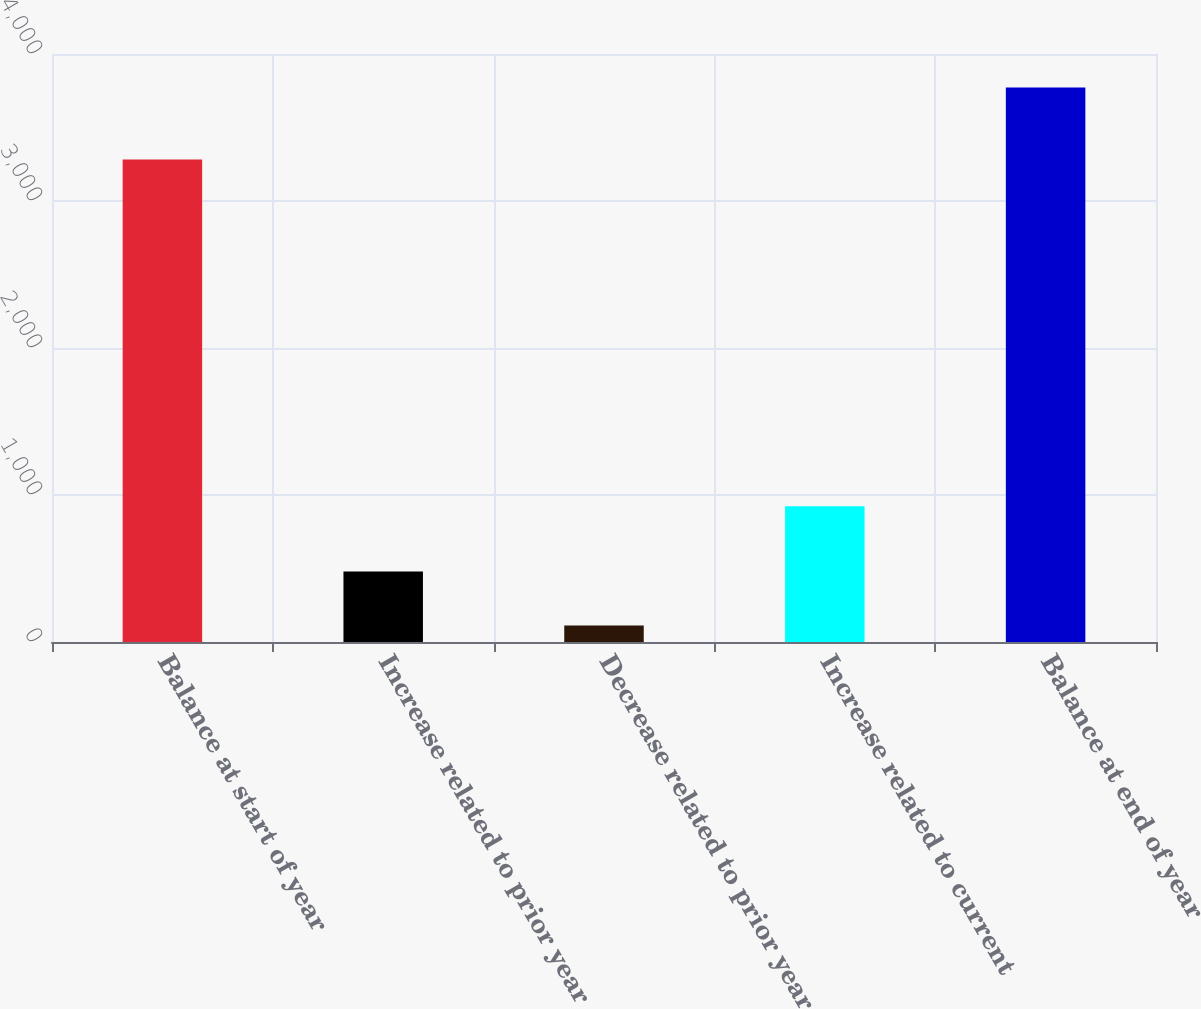<chart> <loc_0><loc_0><loc_500><loc_500><bar_chart><fcel>Balance at start of year<fcel>Increase related to prior year<fcel>Decrease related to prior year<fcel>Increase related to current<fcel>Balance at end of year<nl><fcel>3282<fcel>478.9<fcel>113<fcel>924<fcel>3772<nl></chart> 